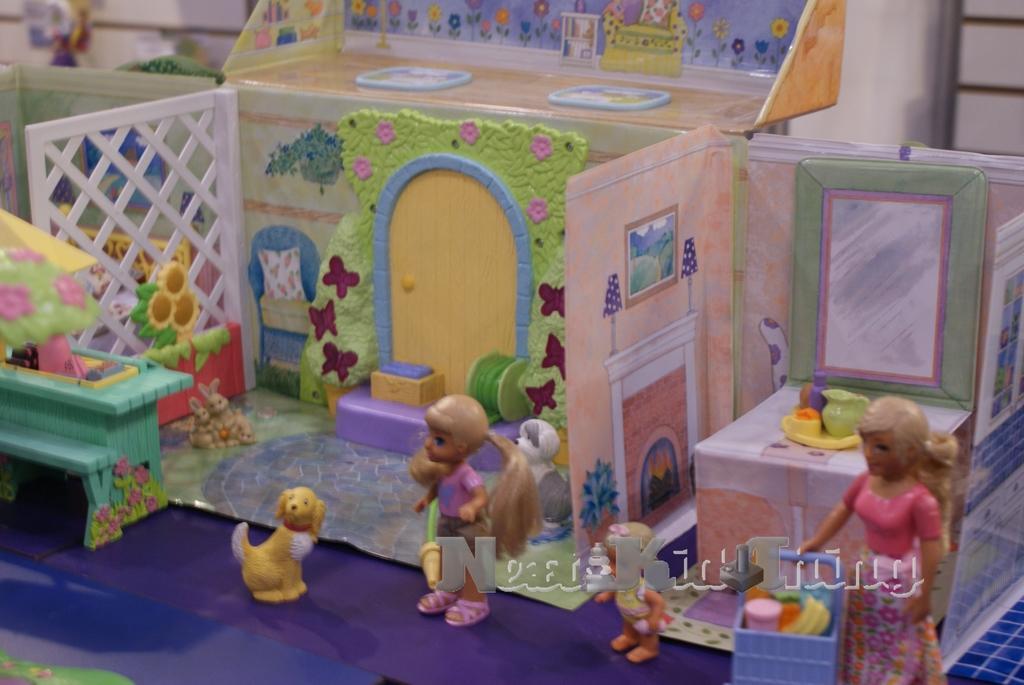How would you summarize this image in a sentence or two? In this picture there is a small miniature toy house made up of cardboard and decorative flowers. Beside there are two dolls and a yellow color small dog. 